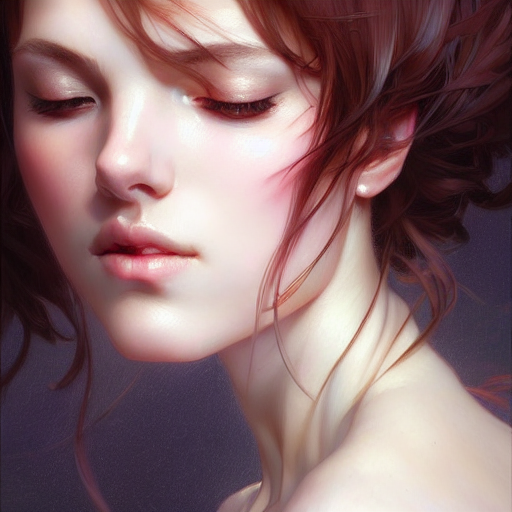Is the quality of this image excellent?
 Yes 